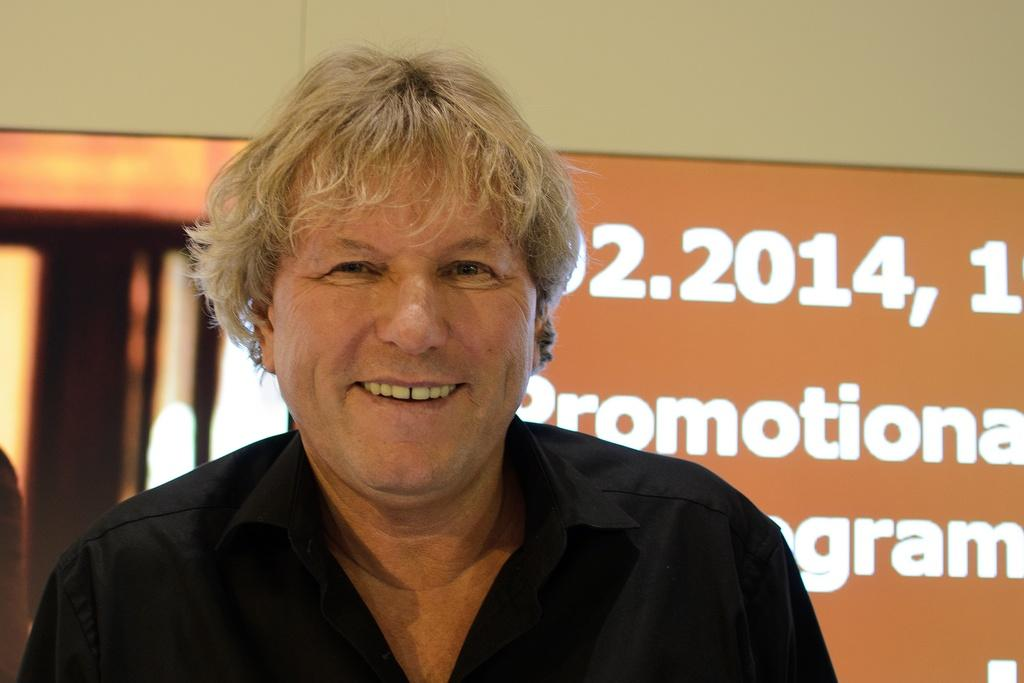What is the main subject of the image? There is a person in the image. What is the person wearing? The person is wearing a black shirt. What is the person's expression in the image? The person is looking and smiling. What can be seen in the background of the image? There is a wall and some text visible in the background. What type of jam is being spread on the railway in the image? There is no jam or railway present in the image; it features a person wearing a black shirt and looking and smiling. 